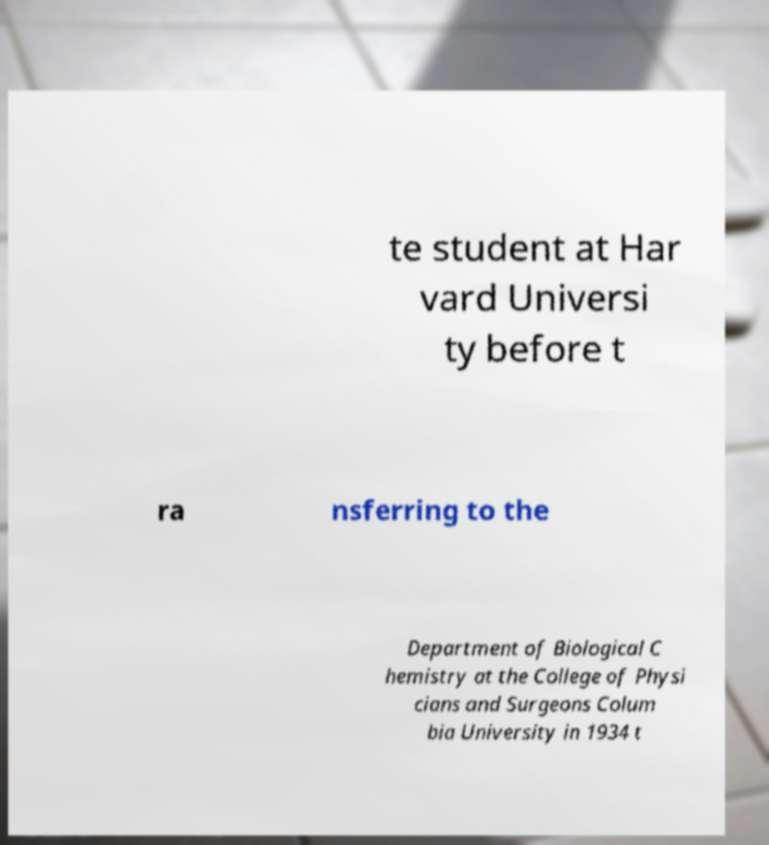There's text embedded in this image that I need extracted. Can you transcribe it verbatim? te student at Har vard Universi ty before t ra nsferring to the Department of Biological C hemistry at the College of Physi cians and Surgeons Colum bia University in 1934 t 